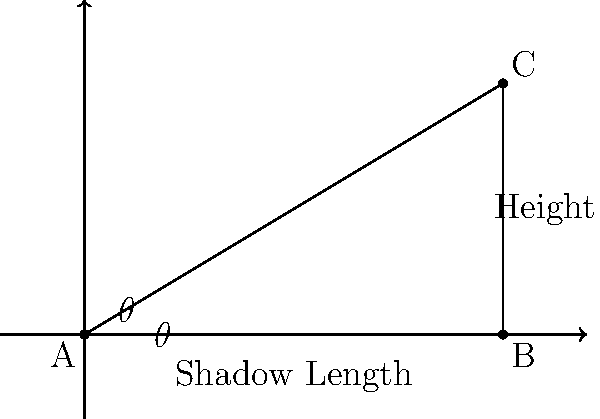As a historical researcher studying ancient architecture, you've discovered records of an ancient lighthouse. The documents mention that when the sun was at an angle of $30^\circ$ above the horizon, the shadow cast by the lighthouse was 40 meters long. Using this information, calculate the height of the ancient lighthouse. To solve this problem, we'll use trigonometry, specifically the tangent function. Let's approach this step-by-step:

1) In a right triangle, tangent of an angle is the ratio of the opposite side to the adjacent side.

2) In our case:
   - The angle $\theta$ is $30^\circ$
   - The adjacent side is the shadow length (40 meters)
   - The opposite side is the lighthouse height (what we're solving for)

3) Let's call the height of the lighthouse $h$. We can write:

   $$\tan(30^\circ) = \frac{h}{40}$$

4) We know that $\tan(30^\circ) = \frac{1}{\sqrt{3}}$, so:

   $$\frac{1}{\sqrt{3}} = \frac{h}{40}$$

5) Cross multiply:

   $$40 \cdot \frac{1}{\sqrt{3}} = h$$

6) Simplify:

   $$h = \frac{40}{\sqrt{3}}$$

7) To get a decimal approximation:

   $$h \approx 23.09 \text{ meters}$$

Therefore, the height of the ancient lighthouse is approximately 23.09 meters.
Answer: $\frac{40}{\sqrt{3}}$ meters (≈ 23.09 meters) 